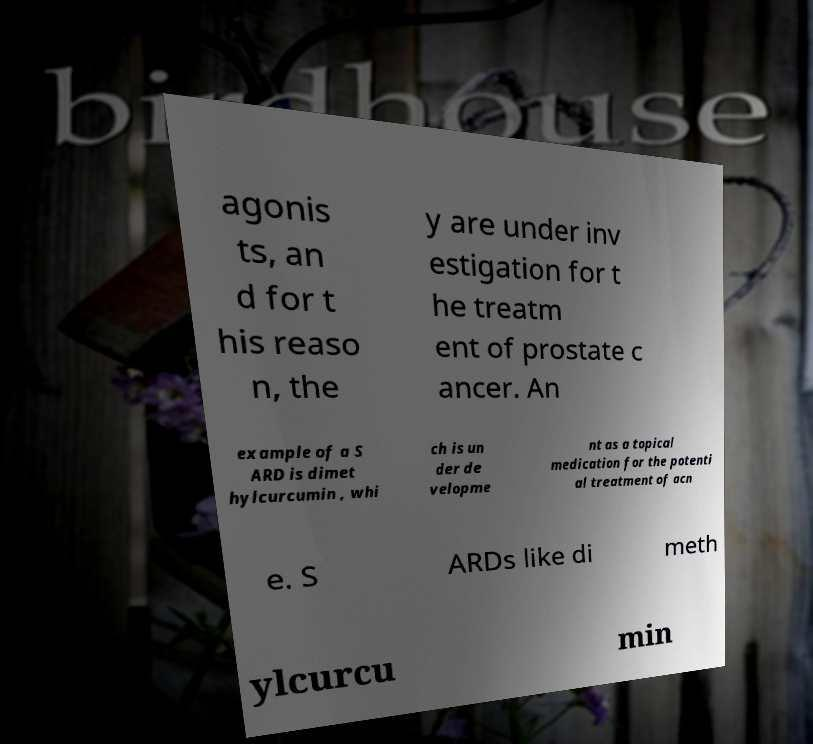What messages or text are displayed in this image? I need them in a readable, typed format. agonis ts, an d for t his reaso n, the y are under inv estigation for t he treatm ent of prostate c ancer. An example of a S ARD is dimet hylcurcumin , whi ch is un der de velopme nt as a topical medication for the potenti al treatment of acn e. S ARDs like di meth ylcurcu min 